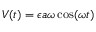Convert formula to latex. <formula><loc_0><loc_0><loc_500><loc_500>V ( t ) = \epsilon a \omega \cos ( \omega t )</formula> 